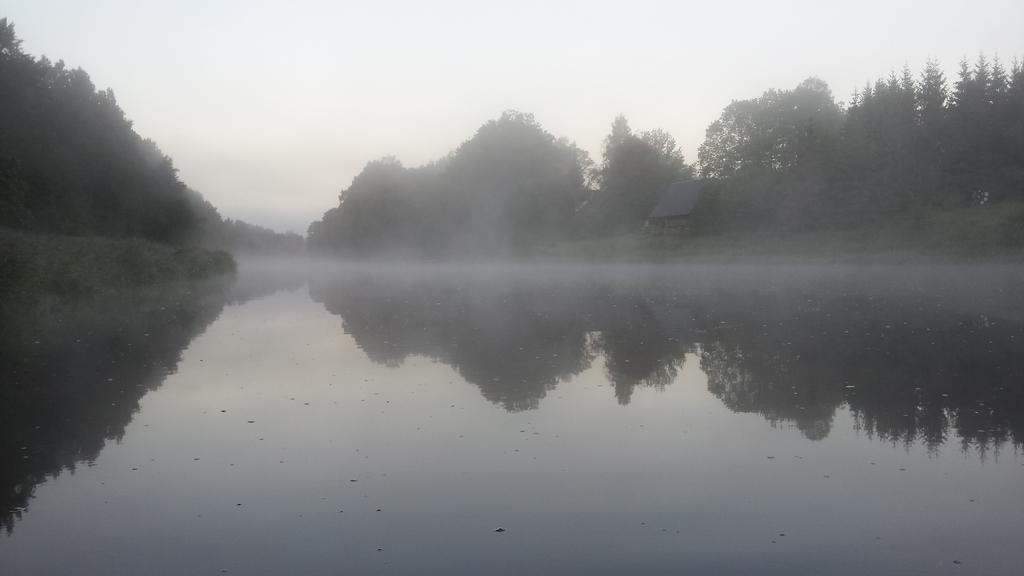What is located at the bottom of the image? There is a pond at the bottom of the image. What can be seen in the background of the image? There are trees, plants, and a house in the background of the image. What is visible at the top of the image? The sky is visible at the top of the image. What type of vegetable is growing near the pond in the image? There is no vegetable growing near the pond in the image. Can you describe the flight of the birds in the image? There are no birds present in the image, so it is not possible to describe their flight. 